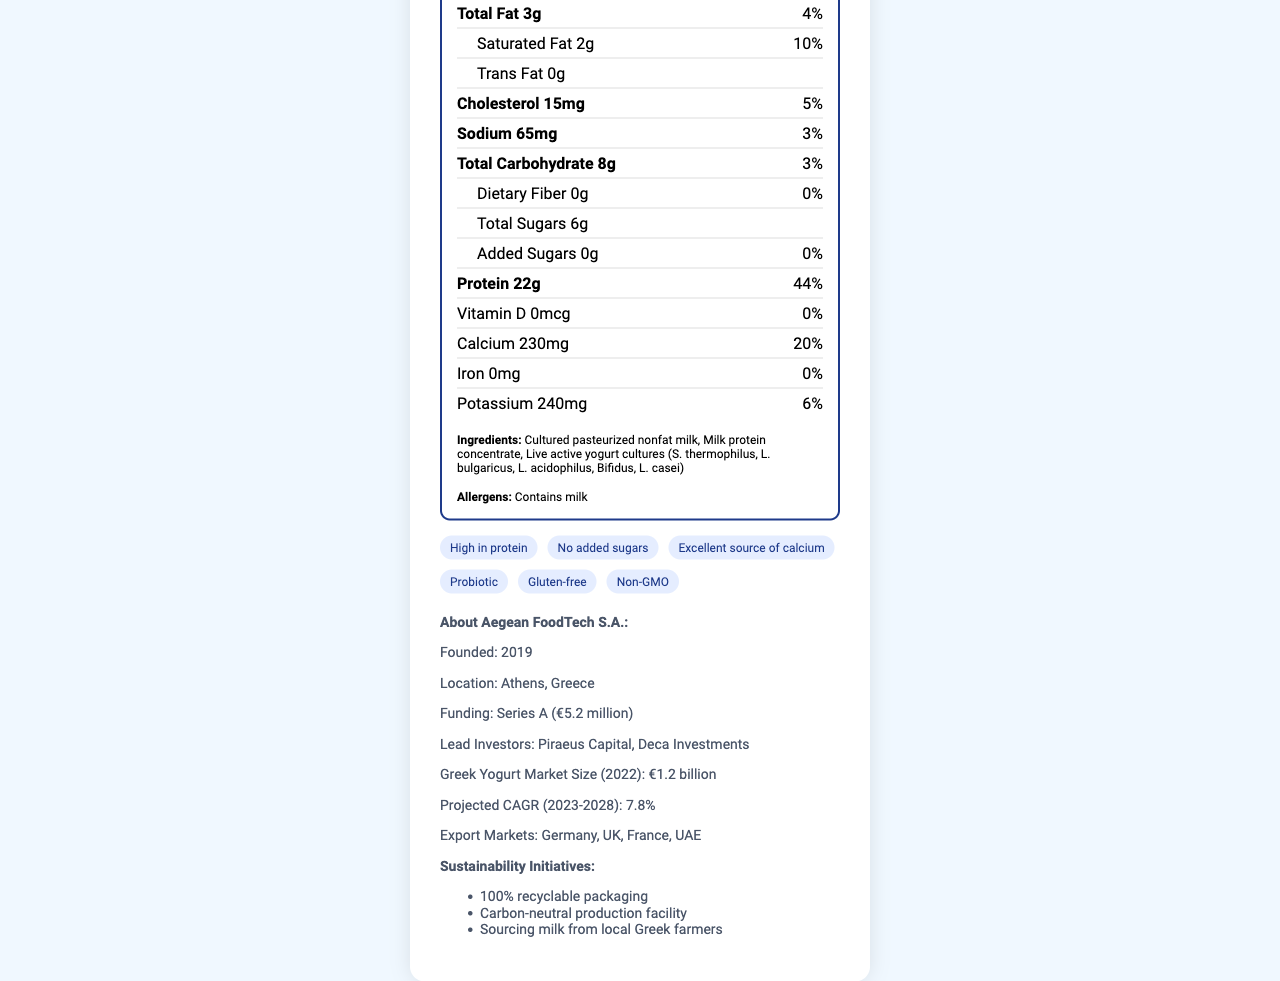who is the manufacturer of Olympus Power Greek Yogurt? The document states that the manufacturer is Aegean FoodTech S.A.
Answer: Aegean FoodTech S.A. what is the serving size for Olympus Power Greek Yogurt? The document specifies the serving size as 170g (3/4 cup).
Answer: 170g (3/4 cup) how many calories per serving are there in Olympus Power Greek Yogurt? The document clearly lists the calories per serving as 150.
Answer: 150 what is the total fat content per serving? The document indicates that the total fat content per serving is 3g.
Answer: 3g what percentage of the daily value does the protein content represent? According to the document, the protein content represents 44% of the daily value.
Answer: 44% which of the following ingredients are included in Olympus Power Greek Yogurt? A. Sugar B. Cultured pasteurized nonfat milk C. Vanilla flavoring D. Artificial sweeteners The document lists the ingredients, and cultured pasteurized nonfat milk is one of them.
Answer: B what are the allergens present in Olympus Power Greek Yogurt? The document mentions that the product contains milk as an allergen.
Answer: Contains milk which claims are true for Olympus Power Greek Yogurt? I. High in protein II. No gluten III. Contains GMOs IV. Added sugars present The document states that the yogurt is high in protein and gluten-free, and it also claims to be non-GMO and has no added sugars.
Answer: I, II is Olympus Power Greek Yogurt an excellent source of calcium? The document claims that the yogurt is an excellent source of calcium.
Answer: Yes describe the main idea of the document. The document covers nutritional facts, ingredients, health claims, and background information about the producing startup, highlighting its sustainability practices.
Answer: The document provides detailed nutritional information about Olympus Power Greek Yogurt, including ingredients, allergens, and health claims. It also includes startup information about the manufacturer, Aegean FoodTech S.A., and their sustainability initiatives. what is the annual growth rate projected for the Greek yogurt market from 2023 to 2028? The document lists the projected CAGR for the Greek yogurt market as 7.8% from 2023 to 2028.
Answer: 7.8% how much funding has Aegean FoodTech S.A. raised so far? The document states that the total funding raised by Aegean FoodTech S.A. is €5.2 million.
Answer: €5.2 million what is the amount of potassium per serving, listed in the document? The document specifies that there are 240mg of potassium per serving.
Answer: 240mg is the production facility for Olympus Power Greek Yogurt carbon-neutral? The document mentions that the production facility is carbon-neutral.
Answer: Yes how many grams of added sugars are in Olympus Power Greek Yogurt? The document lists the amount of added sugars as 0g.
Answer: 0g who are the lead investors in Aegean FoodTech S.A.? The document names Piraeus Capital and Deca Investments as the lead investors.
Answer: Piraeus Capital, Deca Investments does the yogurt contain any artificial sweeteners? The document's ingredients list does not include any artificial sweeteners.
Answer: No how many servings per container are there? The document states that there are 4 servings per container.
Answer: 4 what kind of milk is sourced for making Olympus Power Greek Yogurt? The document mentions that the milk is sourced from local Greek farmers.
Answer: Local Greek farmers' milk does Olympus Power Greek Yogurt contain any iron? The document lists the iron content as 0mg.
Answer: No what year was Aegean FoodTech S.A. founded? The document states that the startup was founded in 2019.
Answer: 2019 which statement is true about how Olympus Power Greek Yogurt is marketed? A. Only in Greece B. Exported to Germany, UK, and France C. Not available in Europe The document lists Germany, UK, and France among the export markets.
Answer: B is there any information about the carbon footprint of the yogurt? The document only mentions that the production facility is carbon-neutral but does not provide specific details about the carbon footprint of the yogurt.
Answer: No information provided 